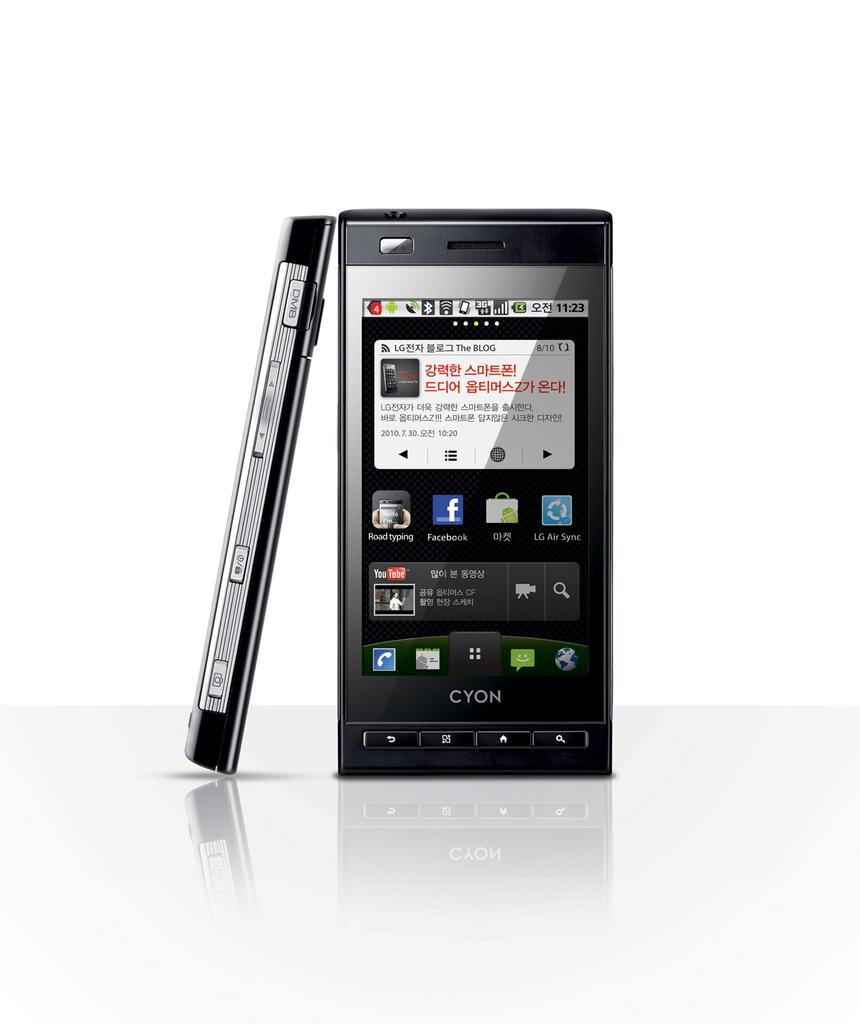<image>
Render a clear and concise summary of the photo. A Cyon electronic device features text in an Asian language. 